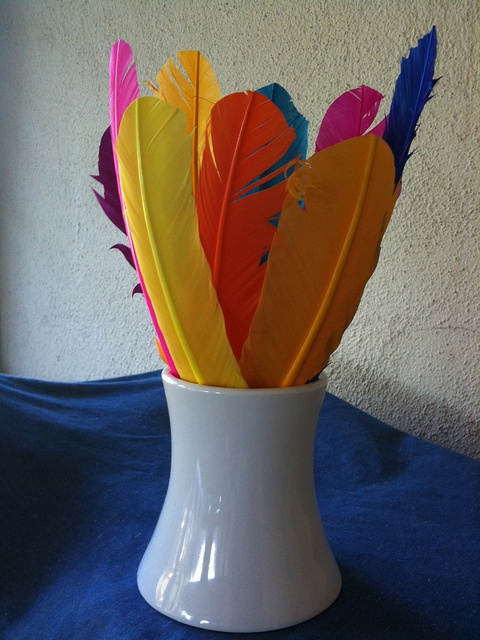Describe the objects in this image and their specific colors. I can see a vase in teal, gray, and darkgray tones in this image. 